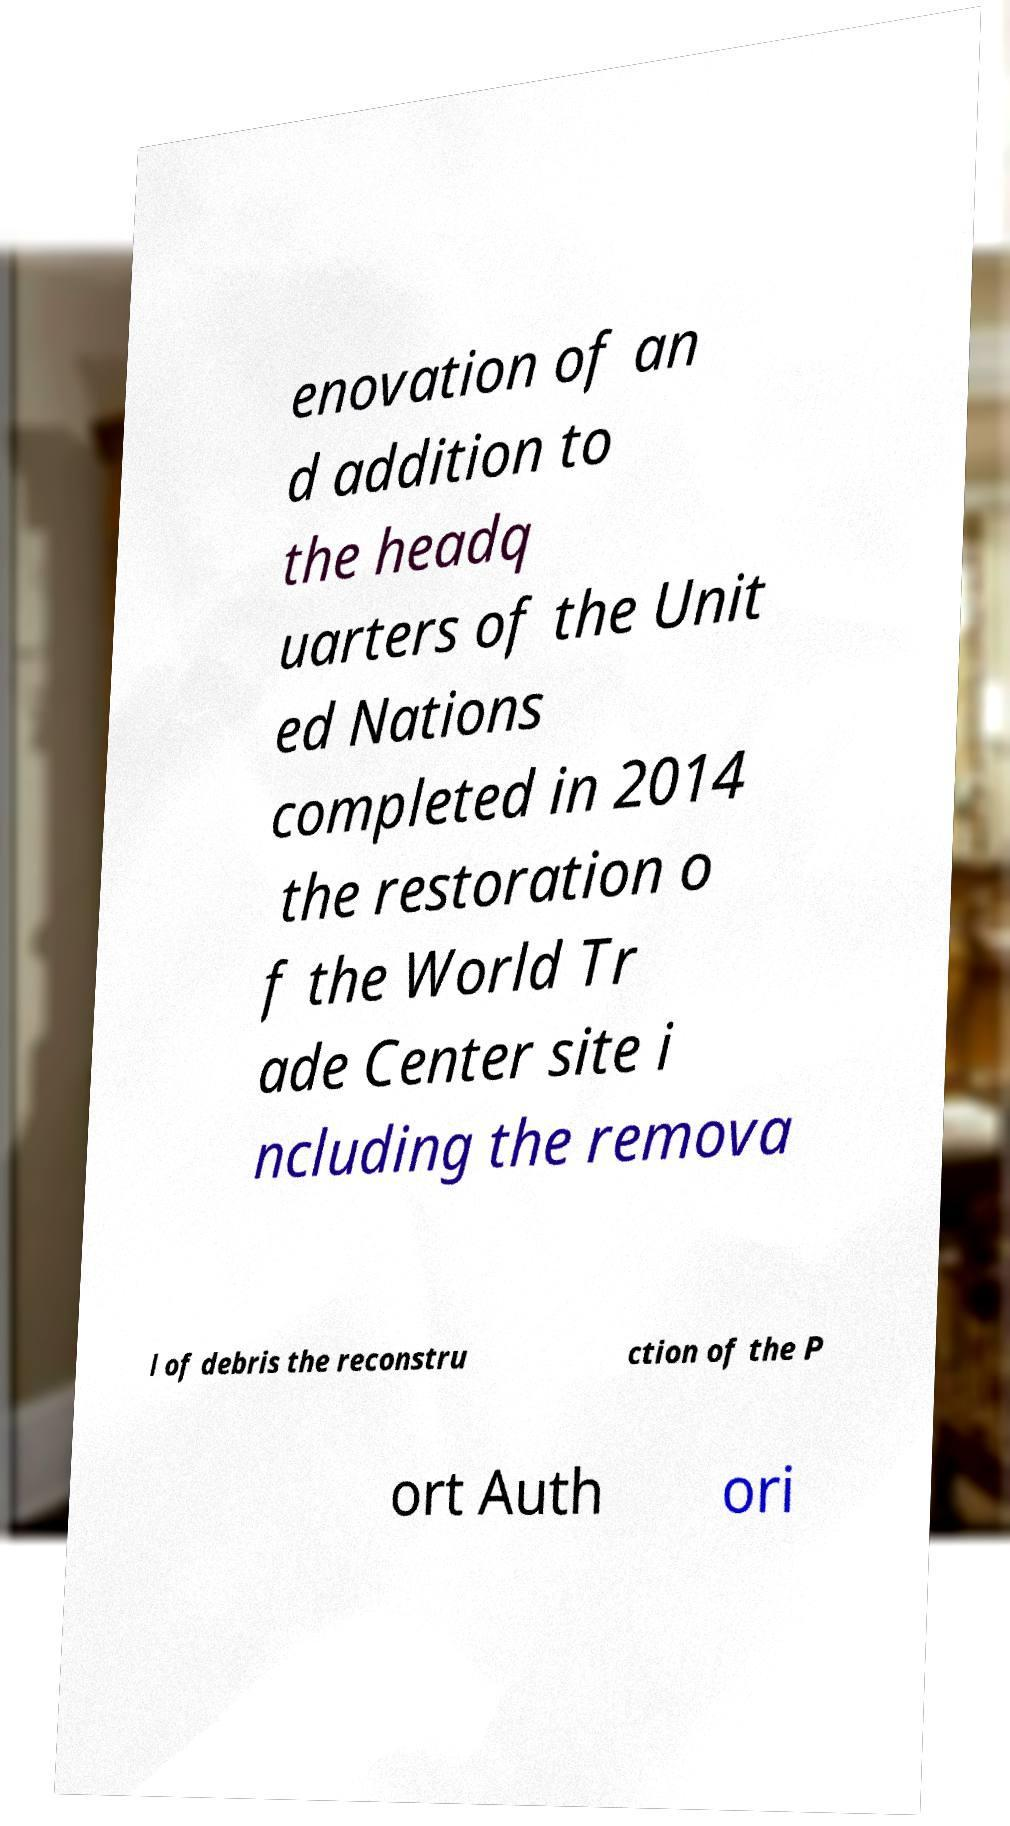Could you assist in decoding the text presented in this image and type it out clearly? enovation of an d addition to the headq uarters of the Unit ed Nations completed in 2014 the restoration o f the World Tr ade Center site i ncluding the remova l of debris the reconstru ction of the P ort Auth ori 